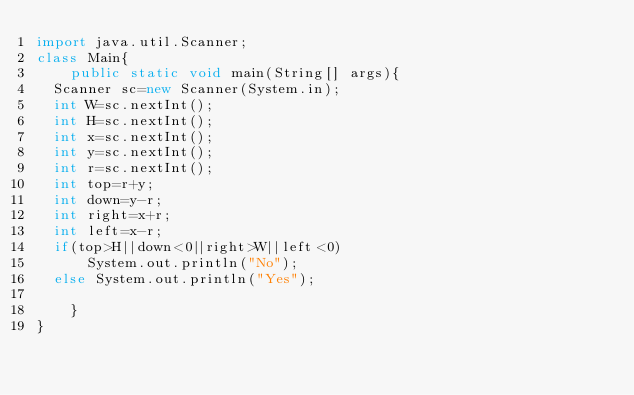<code> <loc_0><loc_0><loc_500><loc_500><_Java_>import java.util.Scanner;
class Main{
    public static void main(String[] args){
	Scanner sc=new Scanner(System.in);
	int W=sc.nextInt();
	int H=sc.nextInt();
	int x=sc.nextInt();
	int y=sc.nextInt();
	int r=sc.nextInt();
	int top=r+y;
	int down=y-r;
	int right=x+r;
	int left=x-r;
	if(top>H||down<0||right>W||left<0)
	    System.out.println("No");
	else System.out.println("Yes");
	
    }
}</code> 